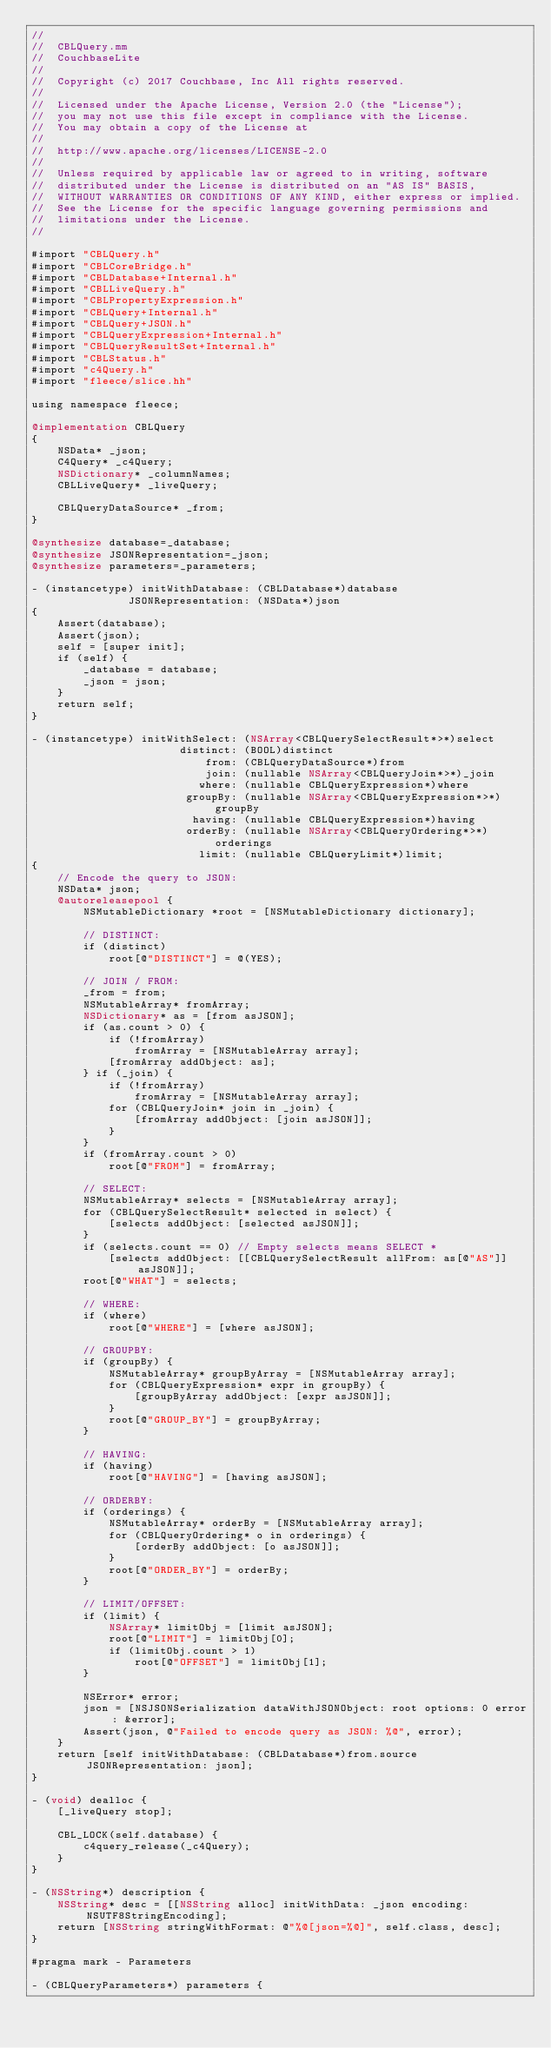<code> <loc_0><loc_0><loc_500><loc_500><_ObjectiveC_>//
//  CBLQuery.mm
//  CouchbaseLite
//
//  Copyright (c) 2017 Couchbase, Inc All rights reserved.
//
//  Licensed under the Apache License, Version 2.0 (the "License");
//  you may not use this file except in compliance with the License.
//  You may obtain a copy of the License at
//
//  http://www.apache.org/licenses/LICENSE-2.0
//
//  Unless required by applicable law or agreed to in writing, software
//  distributed under the License is distributed on an "AS IS" BASIS,
//  WITHOUT WARRANTIES OR CONDITIONS OF ANY KIND, either express or implied.
//  See the License for the specific language governing permissions and
//  limitations under the License.
//

#import "CBLQuery.h"
#import "CBLCoreBridge.h"
#import "CBLDatabase+Internal.h"
#import "CBLLiveQuery.h"
#import "CBLPropertyExpression.h"
#import "CBLQuery+Internal.h"
#import "CBLQuery+JSON.h"
#import "CBLQueryExpression+Internal.h"
#import "CBLQueryResultSet+Internal.h"
#import "CBLStatus.h"
#import "c4Query.h"
#import "fleece/slice.hh"

using namespace fleece;

@implementation CBLQuery
{
    NSData* _json;
    C4Query* _c4Query;
    NSDictionary* _columnNames;
    CBLLiveQuery* _liveQuery;
    
    CBLQueryDataSource* _from;
}

@synthesize database=_database;
@synthesize JSONRepresentation=_json;
@synthesize parameters=_parameters;

- (instancetype) initWithDatabase: (CBLDatabase*)database
               JSONRepresentation: (NSData*)json
{
    Assert(database);
    Assert(json);
    self = [super init];
    if (self) {
        _database = database;
        _json = json;
    }
    return self;
}

- (instancetype) initWithSelect: (NSArray<CBLQuerySelectResult*>*)select
                       distinct: (BOOL)distinct
                           from: (CBLQueryDataSource*)from
                           join: (nullable NSArray<CBLQueryJoin*>*)_join
                          where: (nullable CBLQueryExpression*)where
                        groupBy: (nullable NSArray<CBLQueryExpression*>*)groupBy
                         having: (nullable CBLQueryExpression*)having
                        orderBy: (nullable NSArray<CBLQueryOrdering*>*)orderings
                          limit: (nullable CBLQueryLimit*)limit;
{
    // Encode the query to JSON:
    NSData* json;
    @autoreleasepool {
        NSMutableDictionary *root = [NSMutableDictionary dictionary];

        // DISTINCT:
        if (distinct)
            root[@"DISTINCT"] = @(YES);

        // JOIN / FROM:
        _from = from;
        NSMutableArray* fromArray;
        NSDictionary* as = [from asJSON];
        if (as.count > 0) {
            if (!fromArray)
                fromArray = [NSMutableArray array];
            [fromArray addObject: as];
        } if (_join) {
            if (!fromArray)
                fromArray = [NSMutableArray array];
            for (CBLQueryJoin* join in _join) {
                [fromArray addObject: [join asJSON]];
            }
        }
        if (fromArray.count > 0)
            root[@"FROM"] = fromArray;

        // SELECT:
        NSMutableArray* selects = [NSMutableArray array];
        for (CBLQuerySelectResult* selected in select) {
            [selects addObject: [selected asJSON]];
        }
        if (selects.count == 0) // Empty selects means SELECT *
            [selects addObject: [[CBLQuerySelectResult allFrom: as[@"AS"]] asJSON]];
        root[@"WHAT"] = selects;

        // WHERE:
        if (where)
            root[@"WHERE"] = [where asJSON];

        // GROUPBY:
        if (groupBy) {
            NSMutableArray* groupByArray = [NSMutableArray array];
            for (CBLQueryExpression* expr in groupBy) {
                [groupByArray addObject: [expr asJSON]];
            }
            root[@"GROUP_BY"] = groupByArray;
        }

        // HAVING:
        if (having)
            root[@"HAVING"] = [having asJSON];

        // ORDERBY:
        if (orderings) {
            NSMutableArray* orderBy = [NSMutableArray array];
            for (CBLQueryOrdering* o in orderings) {
                [orderBy addObject: [o asJSON]];
            }
            root[@"ORDER_BY"] = orderBy;
        }

        // LIMIT/OFFSET:
        if (limit) {
            NSArray* limitObj = [limit asJSON];
            root[@"LIMIT"] = limitObj[0];
            if (limitObj.count > 1)
                root[@"OFFSET"] = limitObj[1];
        }
        
        NSError* error;
        json = [NSJSONSerialization dataWithJSONObject: root options: 0 error: &error];
        Assert(json, @"Failed to encode query as JSON: %@", error);
    }
    return [self initWithDatabase: (CBLDatabase*)from.source JSONRepresentation: json];
}

- (void) dealloc {
    [_liveQuery stop];
    
    CBL_LOCK(self.database) {
        c4query_release(_c4Query);
    }
}

- (NSString*) description {
    NSString* desc = [[NSString alloc] initWithData: _json encoding: NSUTF8StringEncoding];
    return [NSString stringWithFormat: @"%@[json=%@]", self.class, desc];
}

#pragma mark - Parameters

- (CBLQueryParameters*) parameters {</code> 